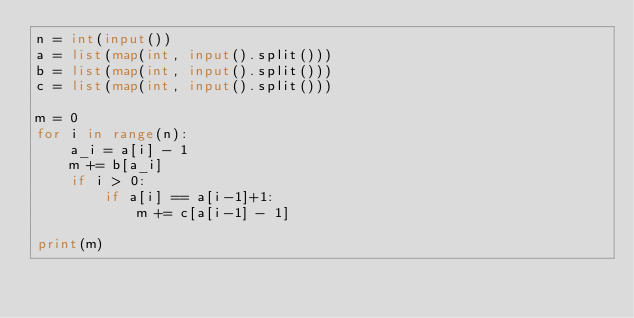Convert code to text. <code><loc_0><loc_0><loc_500><loc_500><_Python_>n = int(input())
a = list(map(int, input().split()))
b = list(map(int, input().split()))
c = list(map(int, input().split()))

m = 0
for i in range(n):
    a_i = a[i] - 1
    m += b[a_i]
    if i > 0:
        if a[i] == a[i-1]+1:
            m += c[a[i-1] - 1]

print(m)</code> 